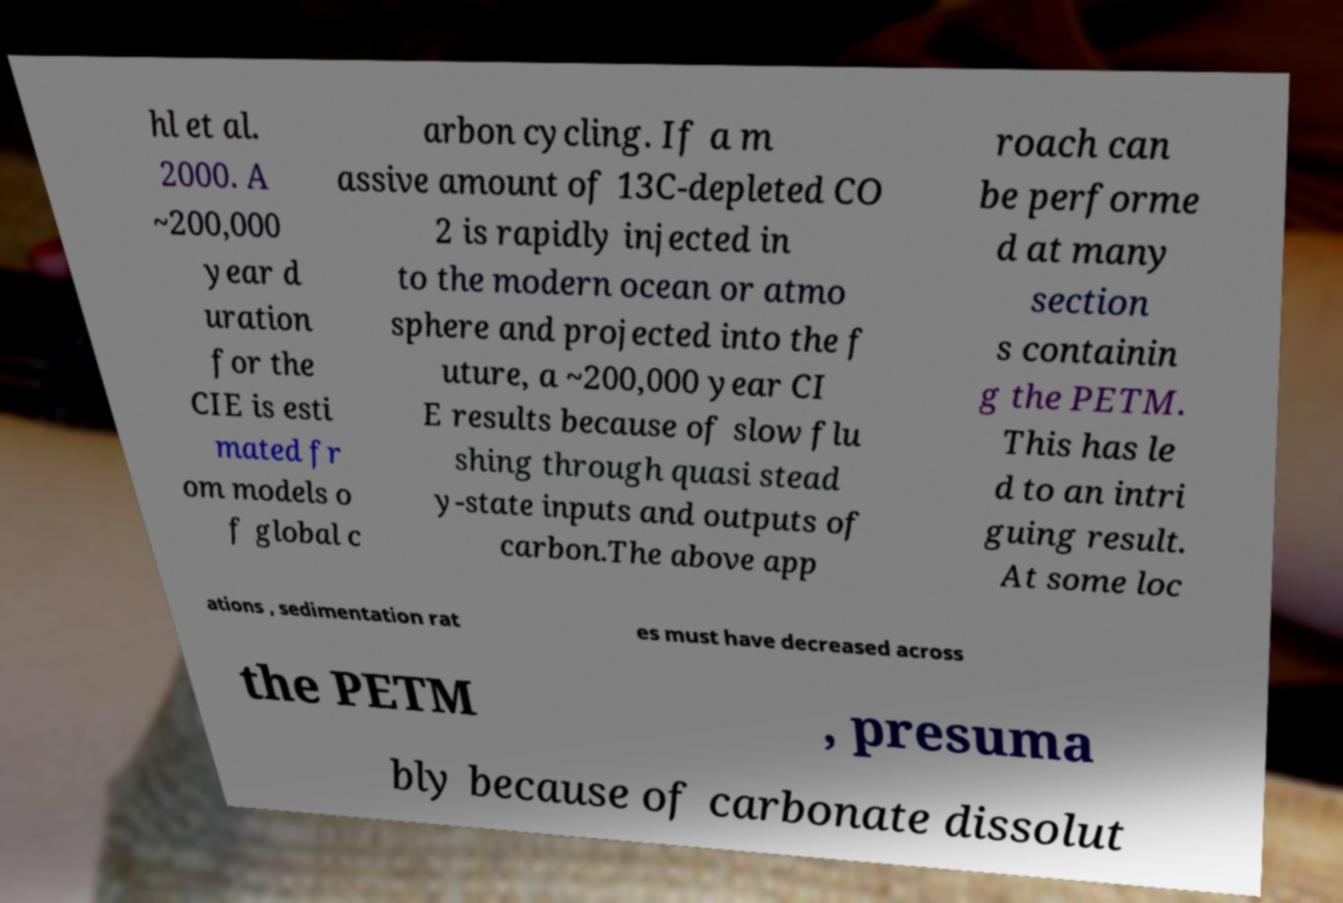Could you extract and type out the text from this image? hl et al. 2000. A ~200,000 year d uration for the CIE is esti mated fr om models o f global c arbon cycling. If a m assive amount of 13C-depleted CO 2 is rapidly injected in to the modern ocean or atmo sphere and projected into the f uture, a ~200,000 year CI E results because of slow flu shing through quasi stead y-state inputs and outputs of carbon.The above app roach can be performe d at many section s containin g the PETM. This has le d to an intri guing result. At some loc ations , sedimentation rat es must have decreased across the PETM , presuma bly because of carbonate dissolut 